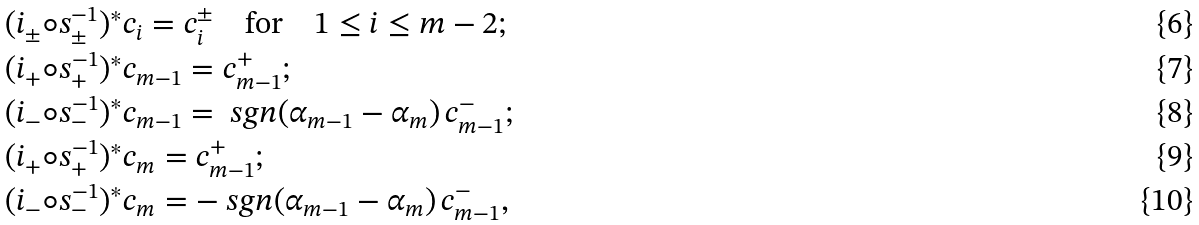Convert formula to latex. <formula><loc_0><loc_0><loc_500><loc_500>& ( i _ { \pm } \circ s _ { \pm } ^ { - 1 } ) ^ { * } c _ { i } = c _ { i } ^ { \pm } \quad \text {for} \quad 1 \leq i \leq m - 2 ; \\ & ( i _ { + } \circ s _ { + } ^ { - 1 } ) ^ { * } c _ { m - 1 } = c _ { m - 1 } ^ { + } ; \\ & ( i _ { - } \circ s _ { - } ^ { - 1 } ) ^ { * } c _ { m - 1 } = \ s g n ( \alpha _ { m - 1 } - \alpha _ { m } ) \, c _ { m - 1 } ^ { - } ; \\ & ( i _ { + } \circ s _ { + } ^ { - 1 } ) ^ { * } c _ { m } = c _ { m - 1 } ^ { + } ; \\ & ( i _ { - } \circ s _ { - } ^ { - 1 } ) ^ { * } c _ { m } = - \ s g n ( \alpha _ { m - 1 } - \alpha _ { m } ) \, c _ { m - 1 } ^ { - } ,</formula> 